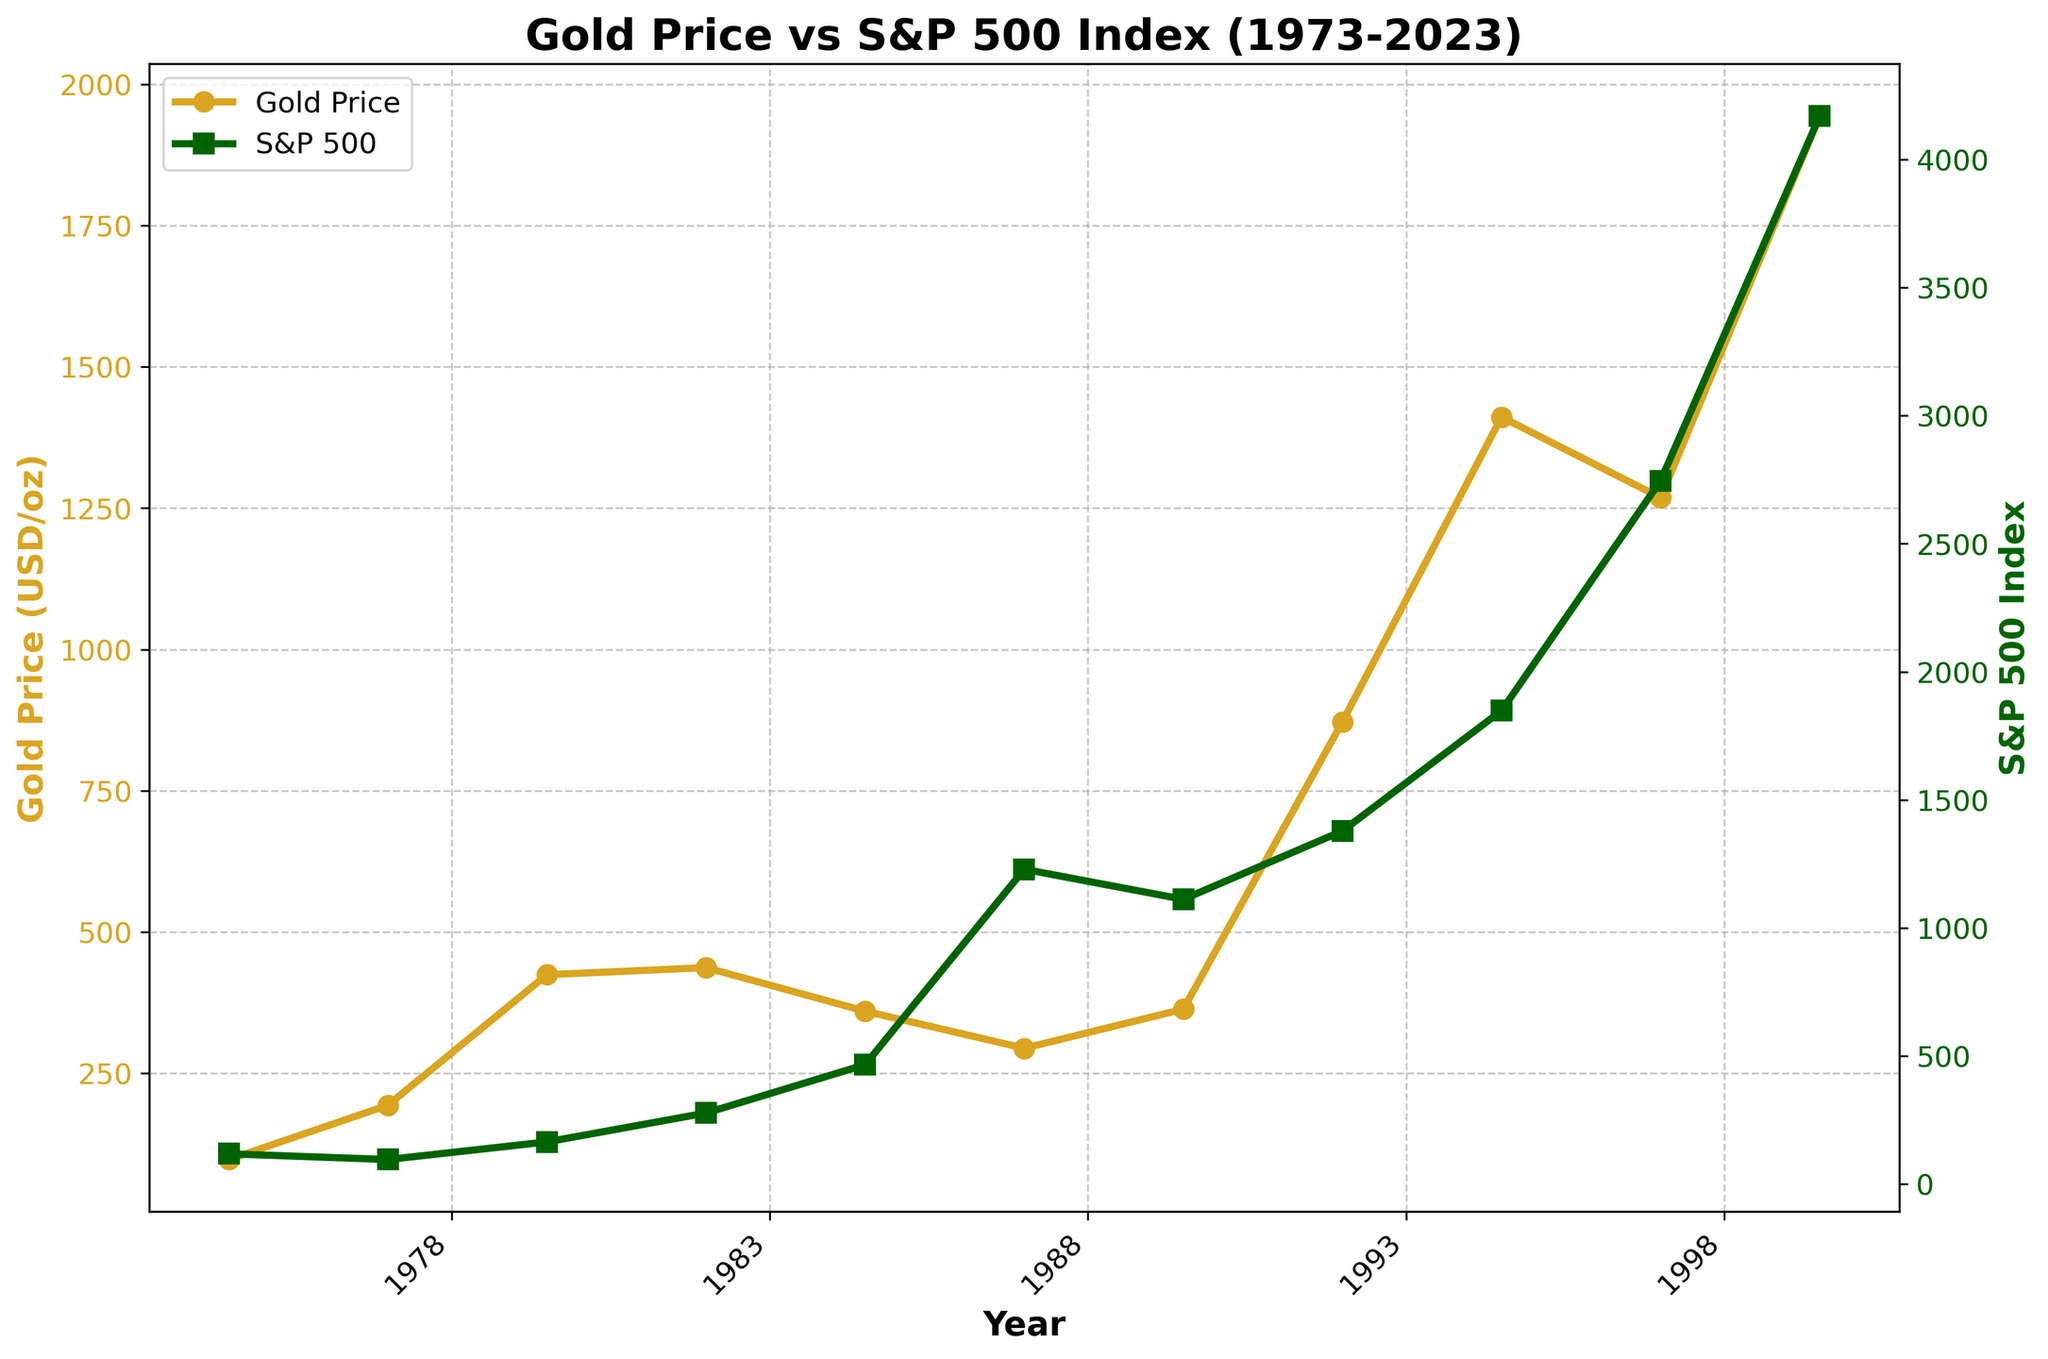which asset showed a more consistent growth trend over the last 50 years? Examine both the gold price and S&P 500 index lines over the entire 50-year period. The S&P 500 index shows a consistent upward trend with minor volatility, while the gold price line has notable peaks and troughs.
Answer: S&P 500 index In which year did the gold price see its highest value? Look for the peak point on the gold price line (colored in goldenrod). The tallest point for gold is in the year 2023.
Answer: 2023 How many times did the S&P 500 index values surpass the gold prices during the last 50 years? Compare the positions of the lines for the S&P 500 index (dark green) and gold price (goldenrod) year by year. In 5 years (1998, 2003, 2008, 2018, 2023), the S&P 500 index is higher than the gold price.
Answer: 5 What is the difference in the value of the S&P 500 index between 1988 and 2023? Subtract the 1988 value from the 2023 value for the S&P 500 index. 4169.48 - 277.72 = 3891.76
Answer: 3891.76 In which decade did gold prices increase the most sharply? Compare the steepness of the gold price line (goldenrod) for each decade. The steepest increase occurs between 2003 and 2008.
Answer: 2000s Which asset experienced a higher percentage increase from 1973 to 2023? Calculate the percentage increase for gold price and S&P 500 index: 
Gold price increase = (1943.8 - 97.32) / 97.32 * 100 ≈ 1897%
S&P 500 index increase = (4169.48 - 118.4) / 118.4 * 100 ≈ 3420%
Answer: S&P 500 index Which year saw the smallest gap between the gold price and S&P 500 index values? Look for the year where the lines representing gold price and S&P 500 index are closest visually. Note the actual values to confirm. In 1983, the gold price is 424.35, and the S&P 500 index is 164.93, showing one of the smallest gaps.
Answer: 1983 During the entire period, which asset looks more volatile based on the visual fluctuations? Compare the fluctuations of the two lines. The gold price line shows more drastic changes compared to the relatively smoother line of the S&P 500 index.
Answer: Gold price In 2008, what is the combined value of the gold price and the S&P 500 index? Add the values of both assets for the year 2008. 871.96 + 1378.76 = 2250.72
Answer: 2250.72 Which asset had a higher value in both 1983 and 2023? Check the values for each year to find that in 1983, the gold price is 424.35, and the S&P 500 index is 164.93. In 2023, the gold price is 1943.80, and the S&P 500 index is 4169.48.
Answer: 1983: Gold price; 
2023: S&P 500 index 